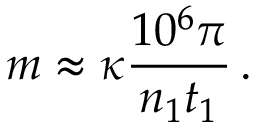<formula> <loc_0><loc_0><loc_500><loc_500>m \approx \kappa \frac { 1 0 ^ { 6 } \pi } { n _ { 1 } t _ { 1 } } \, .</formula> 